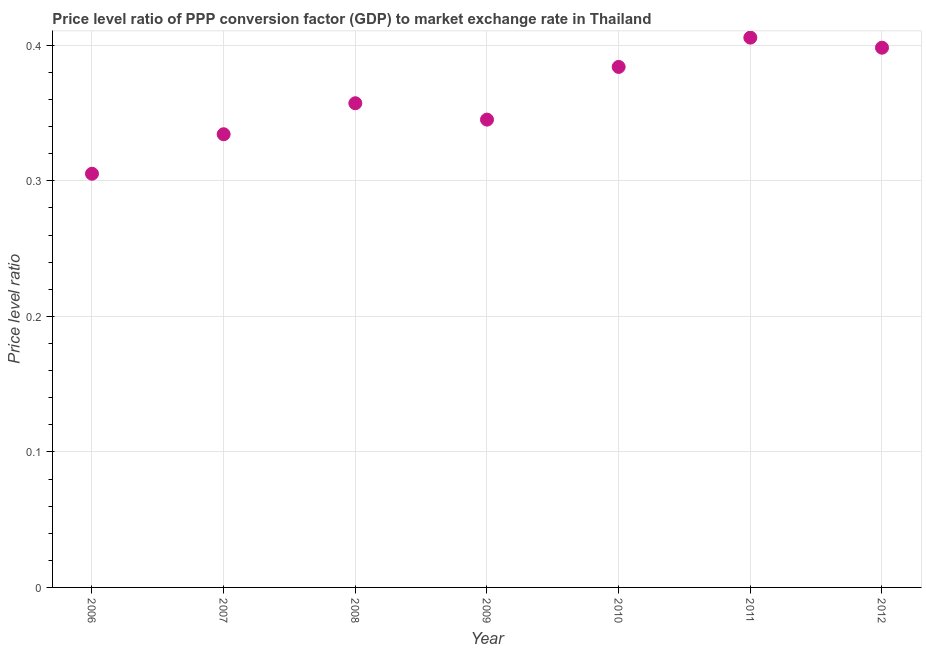What is the price level ratio in 2007?
Keep it short and to the point. 0.33. Across all years, what is the maximum price level ratio?
Offer a terse response. 0.41. Across all years, what is the minimum price level ratio?
Provide a short and direct response. 0.31. In which year was the price level ratio maximum?
Your answer should be very brief. 2011. What is the sum of the price level ratio?
Provide a short and direct response. 2.53. What is the difference between the price level ratio in 2011 and 2012?
Provide a succinct answer. 0.01. What is the average price level ratio per year?
Provide a short and direct response. 0.36. What is the median price level ratio?
Provide a succinct answer. 0.36. Do a majority of the years between 2010 and 2006 (inclusive) have price level ratio greater than 0.14 ?
Your answer should be very brief. Yes. What is the ratio of the price level ratio in 2007 to that in 2011?
Your answer should be very brief. 0.82. Is the price level ratio in 2010 less than that in 2012?
Your answer should be very brief. Yes. Is the difference between the price level ratio in 2007 and 2008 greater than the difference between any two years?
Your response must be concise. No. What is the difference between the highest and the second highest price level ratio?
Your answer should be very brief. 0.01. What is the difference between the highest and the lowest price level ratio?
Keep it short and to the point. 0.1. Does the price level ratio monotonically increase over the years?
Offer a terse response. No. What is the difference between two consecutive major ticks on the Y-axis?
Give a very brief answer. 0.1. Are the values on the major ticks of Y-axis written in scientific E-notation?
Offer a very short reply. No. Does the graph contain any zero values?
Your answer should be very brief. No. Does the graph contain grids?
Provide a succinct answer. Yes. What is the title of the graph?
Your response must be concise. Price level ratio of PPP conversion factor (GDP) to market exchange rate in Thailand. What is the label or title of the Y-axis?
Give a very brief answer. Price level ratio. What is the Price level ratio in 2006?
Provide a succinct answer. 0.31. What is the Price level ratio in 2007?
Offer a very short reply. 0.33. What is the Price level ratio in 2008?
Your answer should be very brief. 0.36. What is the Price level ratio in 2009?
Offer a very short reply. 0.35. What is the Price level ratio in 2010?
Make the answer very short. 0.38. What is the Price level ratio in 2011?
Ensure brevity in your answer.  0.41. What is the Price level ratio in 2012?
Your response must be concise. 0.4. What is the difference between the Price level ratio in 2006 and 2007?
Ensure brevity in your answer.  -0.03. What is the difference between the Price level ratio in 2006 and 2008?
Offer a terse response. -0.05. What is the difference between the Price level ratio in 2006 and 2009?
Keep it short and to the point. -0.04. What is the difference between the Price level ratio in 2006 and 2010?
Provide a succinct answer. -0.08. What is the difference between the Price level ratio in 2006 and 2011?
Your answer should be very brief. -0.1. What is the difference between the Price level ratio in 2006 and 2012?
Ensure brevity in your answer.  -0.09. What is the difference between the Price level ratio in 2007 and 2008?
Give a very brief answer. -0.02. What is the difference between the Price level ratio in 2007 and 2009?
Keep it short and to the point. -0.01. What is the difference between the Price level ratio in 2007 and 2010?
Make the answer very short. -0.05. What is the difference between the Price level ratio in 2007 and 2011?
Make the answer very short. -0.07. What is the difference between the Price level ratio in 2007 and 2012?
Provide a succinct answer. -0.06. What is the difference between the Price level ratio in 2008 and 2009?
Your answer should be very brief. 0.01. What is the difference between the Price level ratio in 2008 and 2010?
Provide a short and direct response. -0.03. What is the difference between the Price level ratio in 2008 and 2011?
Keep it short and to the point. -0.05. What is the difference between the Price level ratio in 2008 and 2012?
Your response must be concise. -0.04. What is the difference between the Price level ratio in 2009 and 2010?
Provide a short and direct response. -0.04. What is the difference between the Price level ratio in 2009 and 2011?
Your response must be concise. -0.06. What is the difference between the Price level ratio in 2009 and 2012?
Your response must be concise. -0.05. What is the difference between the Price level ratio in 2010 and 2011?
Offer a very short reply. -0.02. What is the difference between the Price level ratio in 2010 and 2012?
Make the answer very short. -0.01. What is the difference between the Price level ratio in 2011 and 2012?
Offer a very short reply. 0.01. What is the ratio of the Price level ratio in 2006 to that in 2007?
Offer a very short reply. 0.91. What is the ratio of the Price level ratio in 2006 to that in 2008?
Give a very brief answer. 0.85. What is the ratio of the Price level ratio in 2006 to that in 2009?
Offer a very short reply. 0.88. What is the ratio of the Price level ratio in 2006 to that in 2010?
Offer a very short reply. 0.8. What is the ratio of the Price level ratio in 2006 to that in 2011?
Provide a short and direct response. 0.75. What is the ratio of the Price level ratio in 2006 to that in 2012?
Make the answer very short. 0.77. What is the ratio of the Price level ratio in 2007 to that in 2008?
Provide a succinct answer. 0.94. What is the ratio of the Price level ratio in 2007 to that in 2010?
Your response must be concise. 0.87. What is the ratio of the Price level ratio in 2007 to that in 2011?
Offer a terse response. 0.82. What is the ratio of the Price level ratio in 2007 to that in 2012?
Your response must be concise. 0.84. What is the ratio of the Price level ratio in 2008 to that in 2009?
Keep it short and to the point. 1.03. What is the ratio of the Price level ratio in 2008 to that in 2010?
Give a very brief answer. 0.93. What is the ratio of the Price level ratio in 2008 to that in 2011?
Provide a short and direct response. 0.88. What is the ratio of the Price level ratio in 2008 to that in 2012?
Keep it short and to the point. 0.9. What is the ratio of the Price level ratio in 2009 to that in 2010?
Make the answer very short. 0.9. What is the ratio of the Price level ratio in 2009 to that in 2011?
Keep it short and to the point. 0.85. What is the ratio of the Price level ratio in 2009 to that in 2012?
Your answer should be compact. 0.87. What is the ratio of the Price level ratio in 2010 to that in 2011?
Offer a very short reply. 0.95. What is the ratio of the Price level ratio in 2011 to that in 2012?
Provide a short and direct response. 1.02. 